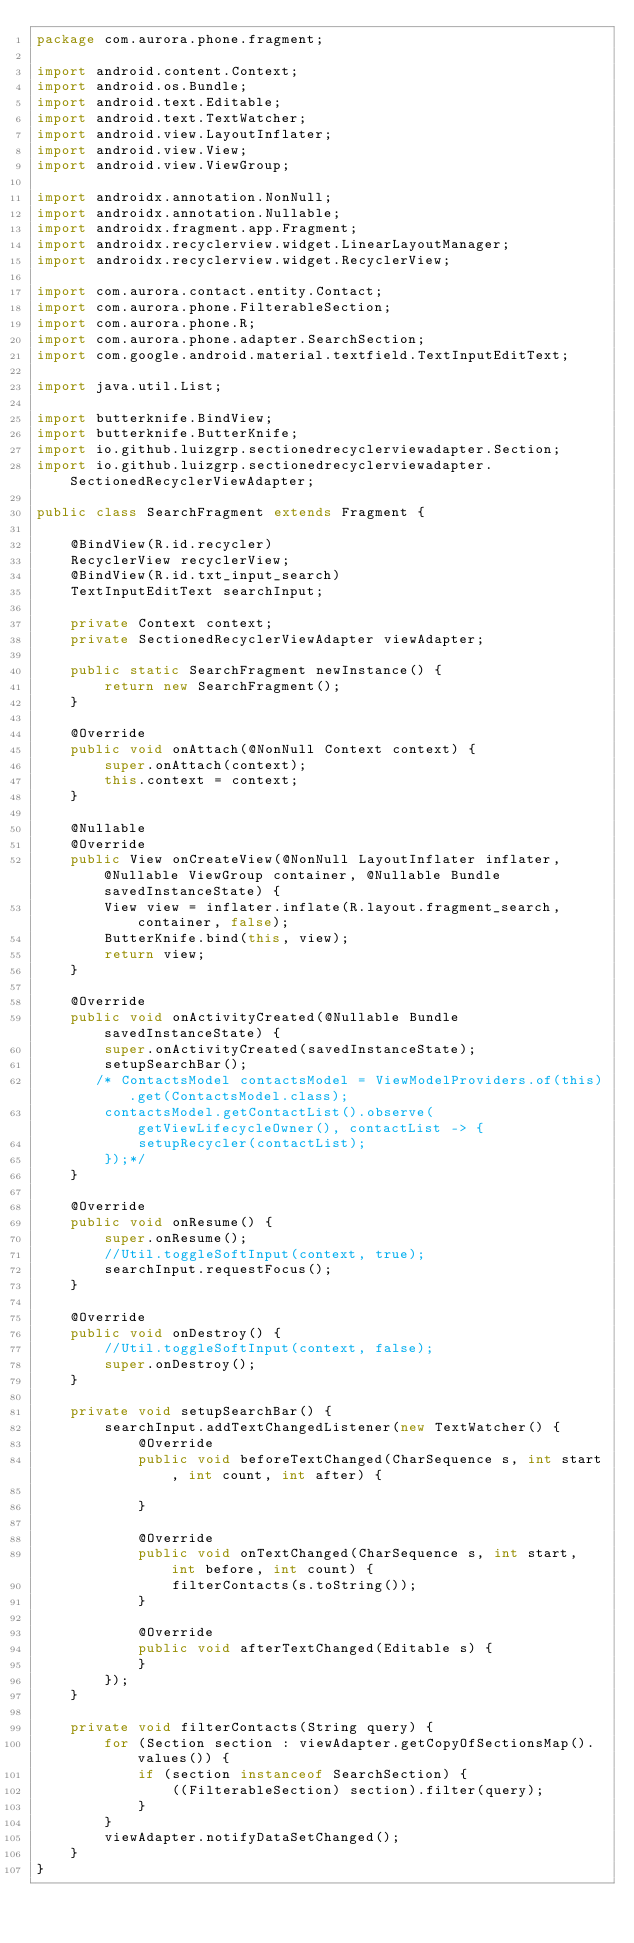<code> <loc_0><loc_0><loc_500><loc_500><_Java_>package com.aurora.phone.fragment;

import android.content.Context;
import android.os.Bundle;
import android.text.Editable;
import android.text.TextWatcher;
import android.view.LayoutInflater;
import android.view.View;
import android.view.ViewGroup;

import androidx.annotation.NonNull;
import androidx.annotation.Nullable;
import androidx.fragment.app.Fragment;
import androidx.recyclerview.widget.LinearLayoutManager;
import androidx.recyclerview.widget.RecyclerView;

import com.aurora.contact.entity.Contact;
import com.aurora.phone.FilterableSection;
import com.aurora.phone.R;
import com.aurora.phone.adapter.SearchSection;
import com.google.android.material.textfield.TextInputEditText;

import java.util.List;

import butterknife.BindView;
import butterknife.ButterKnife;
import io.github.luizgrp.sectionedrecyclerviewadapter.Section;
import io.github.luizgrp.sectionedrecyclerviewadapter.SectionedRecyclerViewAdapter;

public class SearchFragment extends Fragment {

    @BindView(R.id.recycler)
    RecyclerView recyclerView;
    @BindView(R.id.txt_input_search)
    TextInputEditText searchInput;

    private Context context;
    private SectionedRecyclerViewAdapter viewAdapter;

    public static SearchFragment newInstance() {
        return new SearchFragment();
    }

    @Override
    public void onAttach(@NonNull Context context) {
        super.onAttach(context);
        this.context = context;
    }

    @Nullable
    @Override
    public View onCreateView(@NonNull LayoutInflater inflater, @Nullable ViewGroup container, @Nullable Bundle savedInstanceState) {
        View view = inflater.inflate(R.layout.fragment_search, container, false);
        ButterKnife.bind(this, view);
        return view;
    }

    @Override
    public void onActivityCreated(@Nullable Bundle savedInstanceState) {
        super.onActivityCreated(savedInstanceState);
        setupSearchBar();
       /* ContactsModel contactsModel = ViewModelProviders.of(this).get(ContactsModel.class);
        contactsModel.getContactList().observe(getViewLifecycleOwner(), contactList -> {
            setupRecycler(contactList);
        });*/
    }

    @Override
    public void onResume() {
        super.onResume();
        //Util.toggleSoftInput(context, true);
        searchInput.requestFocus();
    }

    @Override
    public void onDestroy() {
        //Util.toggleSoftInput(context, false);
        super.onDestroy();
    }

    private void setupSearchBar() {
        searchInput.addTextChangedListener(new TextWatcher() {
            @Override
            public void beforeTextChanged(CharSequence s, int start, int count, int after) {

            }

            @Override
            public void onTextChanged(CharSequence s, int start, int before, int count) {
                filterContacts(s.toString());
            }

            @Override
            public void afterTextChanged(Editable s) {
            }
        });
    }

    private void filterContacts(String query) {
        for (Section section : viewAdapter.getCopyOfSectionsMap().values()) {
            if (section instanceof SearchSection) {
                ((FilterableSection) section).filter(query);
            }
        }
        viewAdapter.notifyDataSetChanged();
    }
}
</code> 